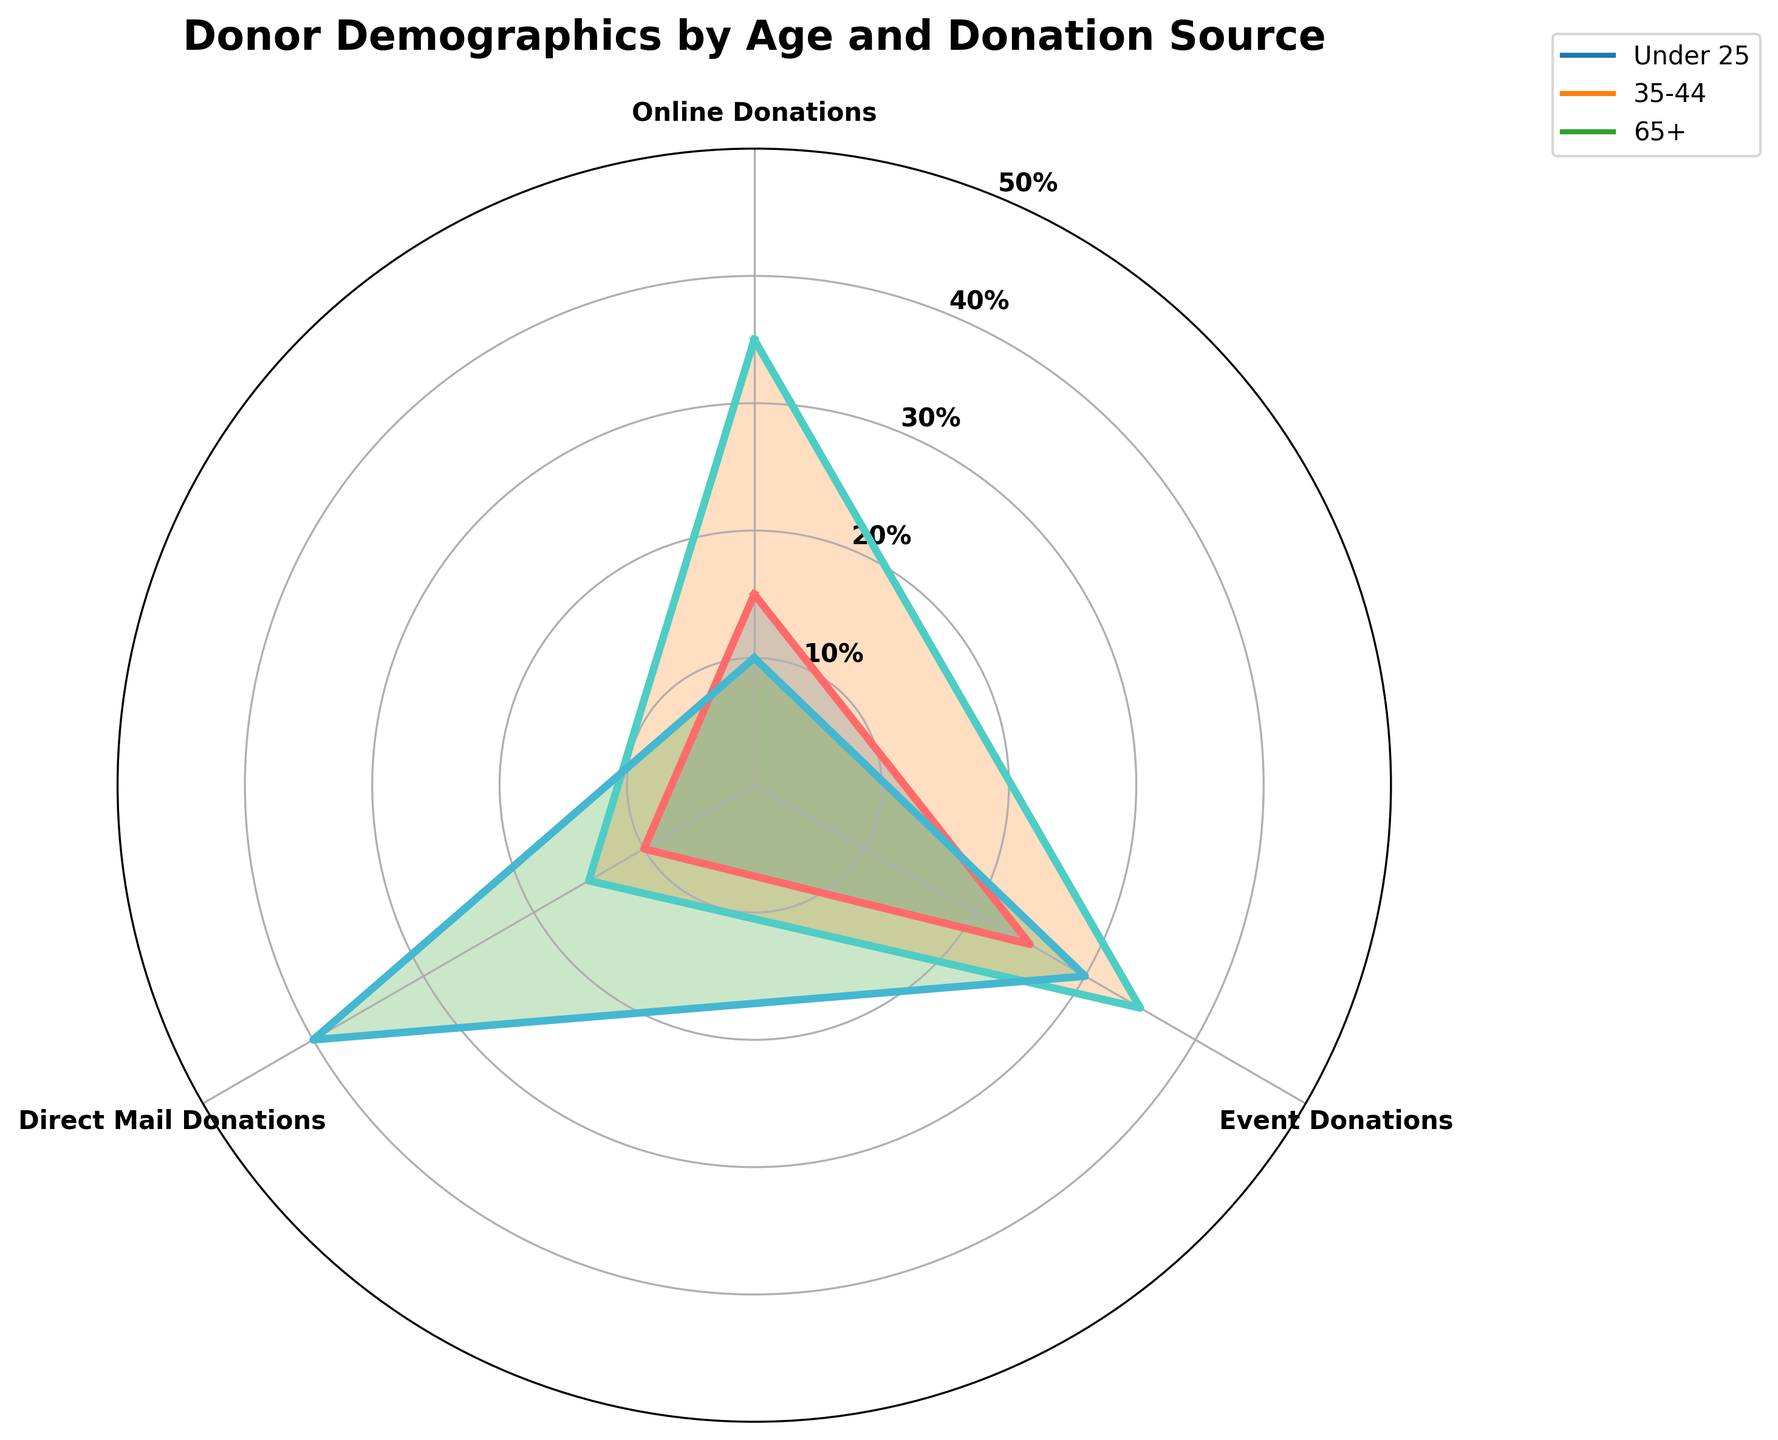What's the title of the chart? The title of the chart is usually placed at the top. It is "Donor Demographics by Age and Donation Source".
Answer: Donor Demographics by Age and Donation Source What are the three age groups shown in the chart? By examining the radial axes' labels, we can identify the three age groups shown as 'Under 25', '35-44', and '65+'.
Answer: Under 25, 35-44, 65+ Which donation source has the highest percentage for the age 'Under 25'? We need to look at the values plotted for 'Under 25' in each donation source segment. The highest value is 25 in 'Events'.
Answer: Events What is the range of values displayed on the radial scale? The radial scale has labels at different intervals. Observing these, we see the range goes from 0 to 50.
Answer: 0 to 50 Which age group has the largest area covered on the radar chart? To determine the group with the largest area, we need to look at the groups' plots that enclose the most space. '35-44' has higher values in most categories compared to 'Under 25' and '65+'.
Answer: 35-44 How do the 'Online Donations' for '35-44' compare to '65+'? Looking at the chart, 'Online Donations' for '35-44' is 35, whereas for '65+' it is 10. 35 is greater than 10.
Answer: 'Online Donations' for '35-44' are greater than '65+' What is the average percentage of 'Direct Mail Donations' across the three age groups? Sum the 'Direct Mail Donations' values for 'Under 25' (10), '35-44' (15), and '65+' (40). The total is 65. The average is 65/3 ≈ 21.67.
Answer: 21.67 Compare the 'Event Donations' between 'Under 25' and '35-44'. Which group donates more via events? 'Event Donations' for 'Under 25' is 25, and for '35-44' it is 35. Hence, '35-44' has higher Event Donations.
Answer: 35-44 Which donation source shows the most contrast in percentages between 'Under 25' and '65+'? By comparing the plotted lines for each source, we see 'Direct Mail Donations' shows a major difference - 10 for 'Under 25' and 40 for '65+'.
Answer: Direct Mail Donations 